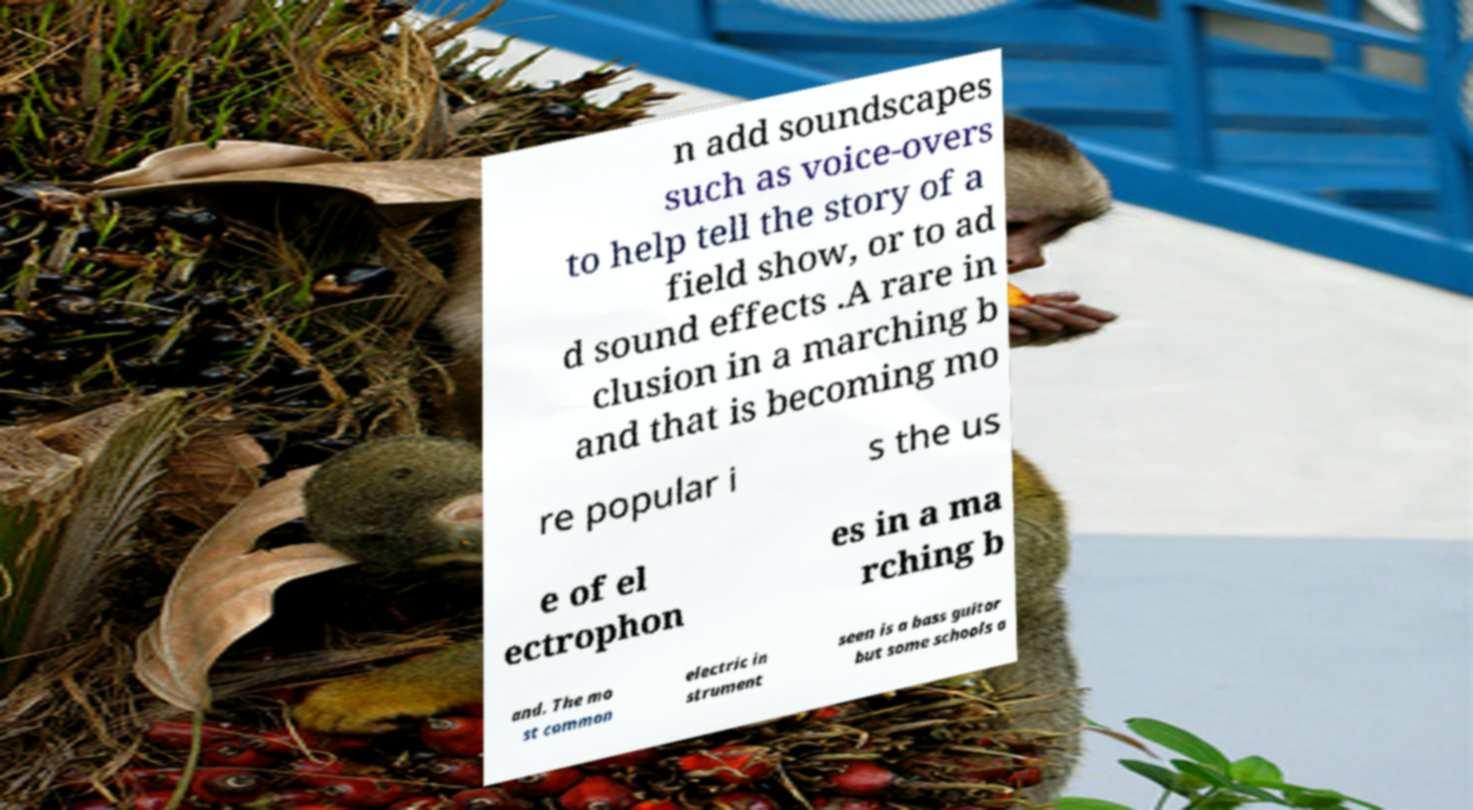I need the written content from this picture converted into text. Can you do that? n add soundscapes such as voice-overs to help tell the story of a field show, or to ad d sound effects .A rare in clusion in a marching b and that is becoming mo re popular i s the us e of el ectrophon es in a ma rching b and. The mo st common electric in strument seen is a bass guitar but some schools a 